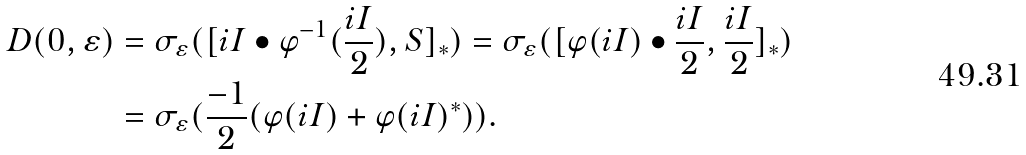Convert formula to latex. <formula><loc_0><loc_0><loc_500><loc_500>D ( 0 , \varepsilon ) & = \sigma _ { \varepsilon } ( [ i I \bullet \varphi ^ { - 1 } ( \frac { i I } { 2 } ) , S ] _ { \ast } ) = \sigma _ { \varepsilon } ( [ \varphi ( i I ) \bullet \frac { i I } { 2 } , \frac { i I } { 2 } ] _ { \ast } ) \\ & = \sigma _ { \varepsilon } ( \frac { - 1 } { 2 } ( \varphi ( i I ) + \varphi ( i I ) ^ { \ast } ) ) .</formula> 